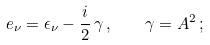<formula> <loc_0><loc_0><loc_500><loc_500>e _ { \nu } = \epsilon _ { \nu } - \frac { i } { 2 } \, \gamma \, , \quad \gamma = A ^ { 2 } \, ;</formula> 